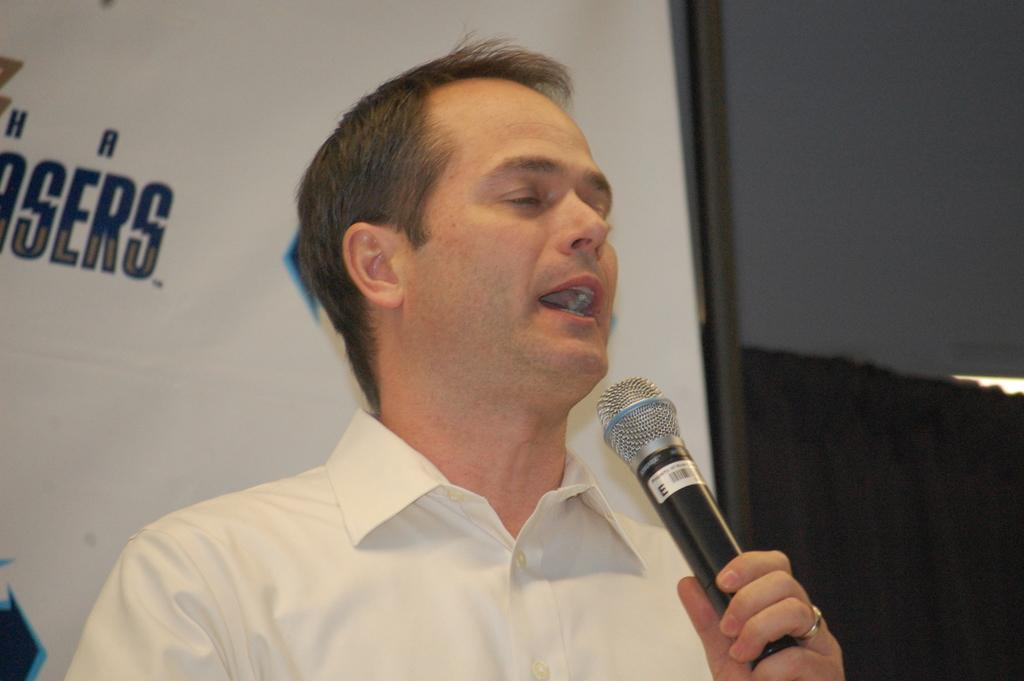Who is the main subject in the image? There is a man in the center of the image. What is the man holding in his hand? The man is holding a microphone in his hand. What is the man doing in the image? The man is speaking. What type of juice can be seen flowing from the man's hand in the image? There is no juice present in the image; the man is holding a microphone. 